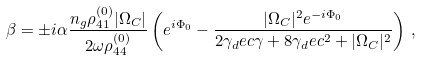Convert formula to latex. <formula><loc_0><loc_0><loc_500><loc_500>\beta = \pm i \alpha \frac { n _ { g } \rho _ { 4 1 } ^ { ( 0 ) } | \Omega _ { C } | } { 2 \omega \rho _ { 4 4 } ^ { ( 0 ) } } \left ( e ^ { i \Phi _ { 0 } } - \frac { | \Omega _ { C } | ^ { 2 } e ^ { - i \Phi _ { 0 } } } { 2 \gamma _ { d } e c \gamma + 8 \gamma _ { d } e c ^ { 2 } + | \Omega _ { C } | ^ { 2 } } \right ) \, ,</formula> 